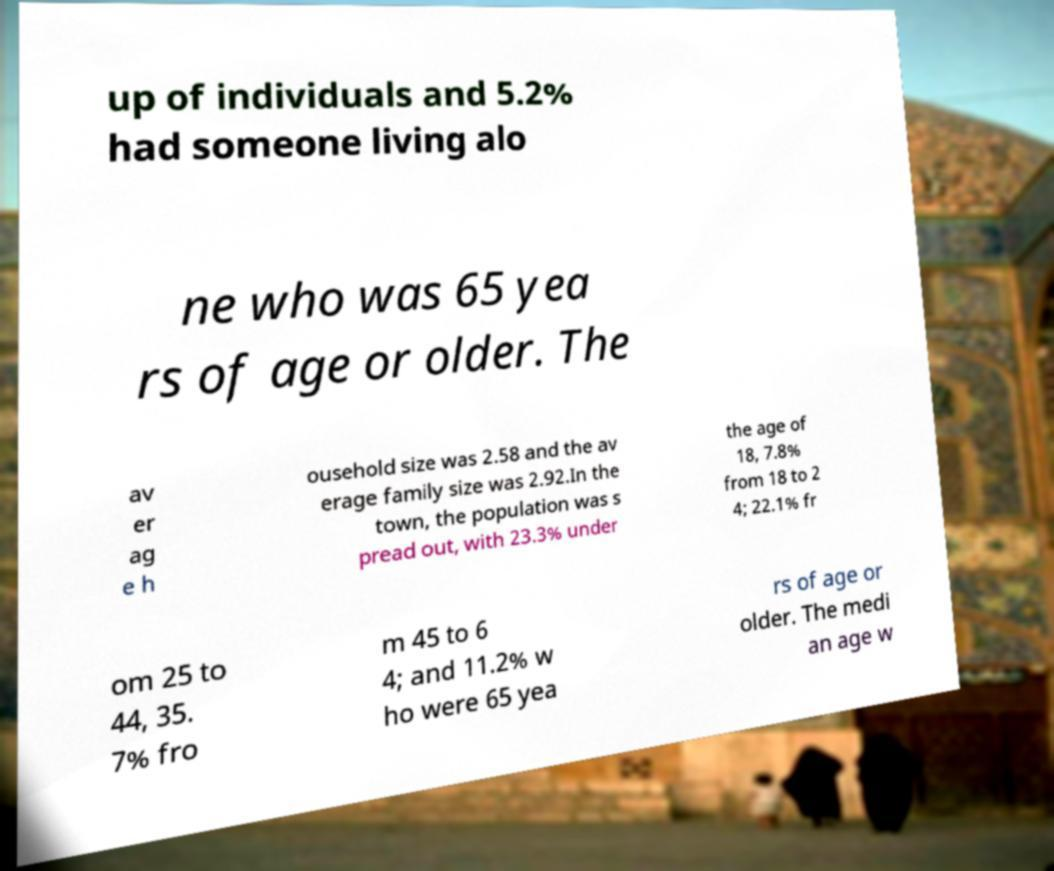Please identify and transcribe the text found in this image. up of individuals and 5.2% had someone living alo ne who was 65 yea rs of age or older. The av er ag e h ousehold size was 2.58 and the av erage family size was 2.92.In the town, the population was s pread out, with 23.3% under the age of 18, 7.8% from 18 to 2 4; 22.1% fr om 25 to 44, 35. 7% fro m 45 to 6 4; and 11.2% w ho were 65 yea rs of age or older. The medi an age w 